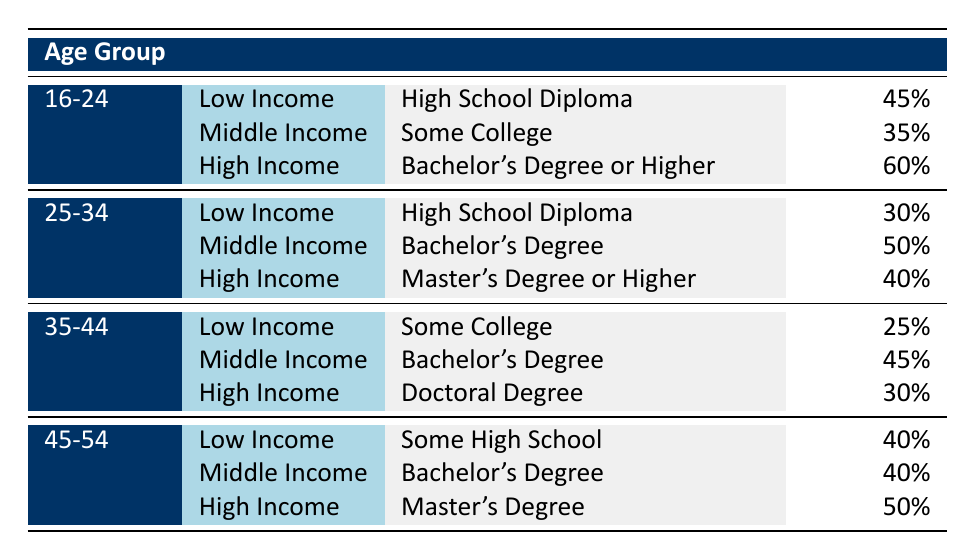What percentage of the Low Income group aged 16-24 has a High School Diploma? According to the table, the educational attainment for the Low Income group in the age range of 16-24 is a High School Diploma, and the percentage is directly presented as 45%.
Answer: 45% What is the average educational attainment level for Middle Income individuals aged 25-34? The table indicates that for the Middle Income category in the age group of 25-34, the average educational attainment is a Bachelor's Degree, as specified in the corresponding row.
Answer: Bachelor's Degree Is there a higher percentage of High Income individuals with a Master's Degree or Higher in the 25-34 age group compared to the 35-44 age group? The table shows that for the 25-34 age group, 40% of High Income individuals have a Master's Degree or Higher, while for the 35-44 age group, 30% have a Doctoral Degree. Since 40% is greater than 30%, the answer is yes.
Answer: Yes How many age groups have Low Income individuals who attain educational levels higher than Some High School? By examining the table, the age groups of 16-24 and 25-34 show that Low Income individuals attain either a High School Diploma (45% and 30%, respectively) but the 35-44 age group and the 45-54 age group are at Some College and Some High School respectively. Hence, only two age groups have Low Income individuals surpassing Some High School—those aged 16-24 and 25-34.
Answer: 2 What is the difference in percentage of individuals achieving Bachelor's Degrees between Middle Income individuals aged 25-34 and 35-44? For Middle Income individuals aged 25-34, the percentage achieving a Bachelor's Degree is 50%, while for those aged 35-44, it is 45%. The difference can be calculated as 50% - 45% = 5%.
Answer: 5% 